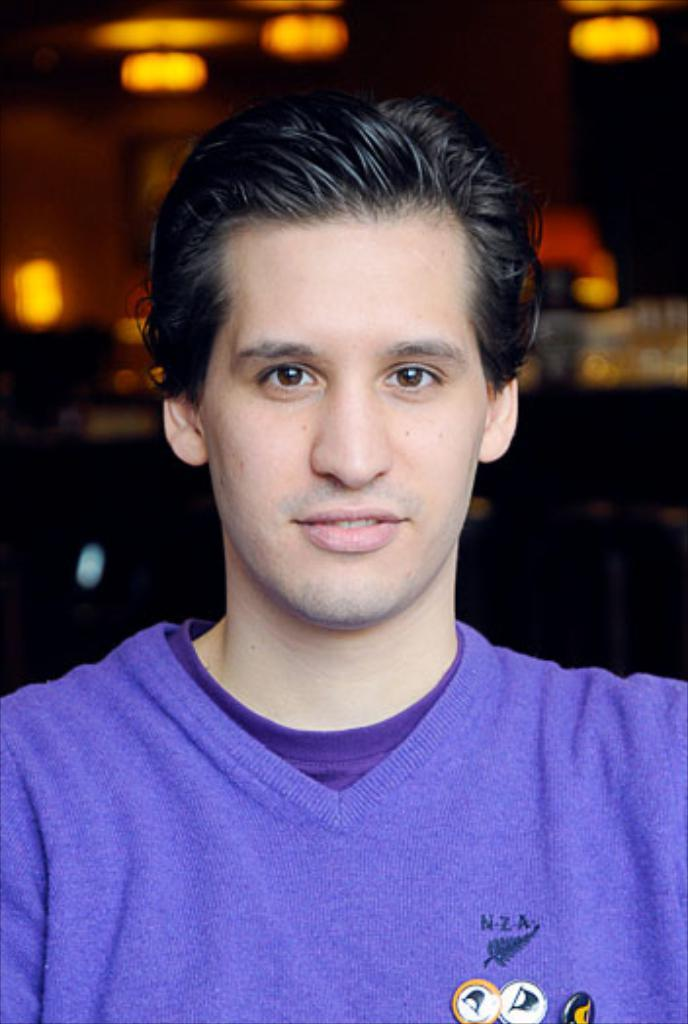Who is present in the image? There is a man in the image. What is the appearance of the man's face? The man is clean shaven. What color is the dress the man is wearing? The man is wearing a violet color dress. What is the color of the man's hair? The man has black hair. How many pizzas are on the calendar in the image? There is no calendar or pizzas present in the image. 